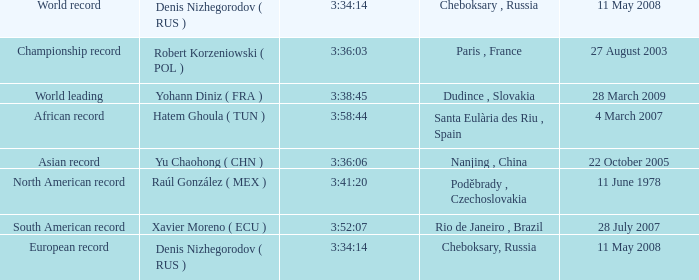When 3:38:45 is  3:34:14 what is the date on May 11th, 2008? 28 March 2009. 